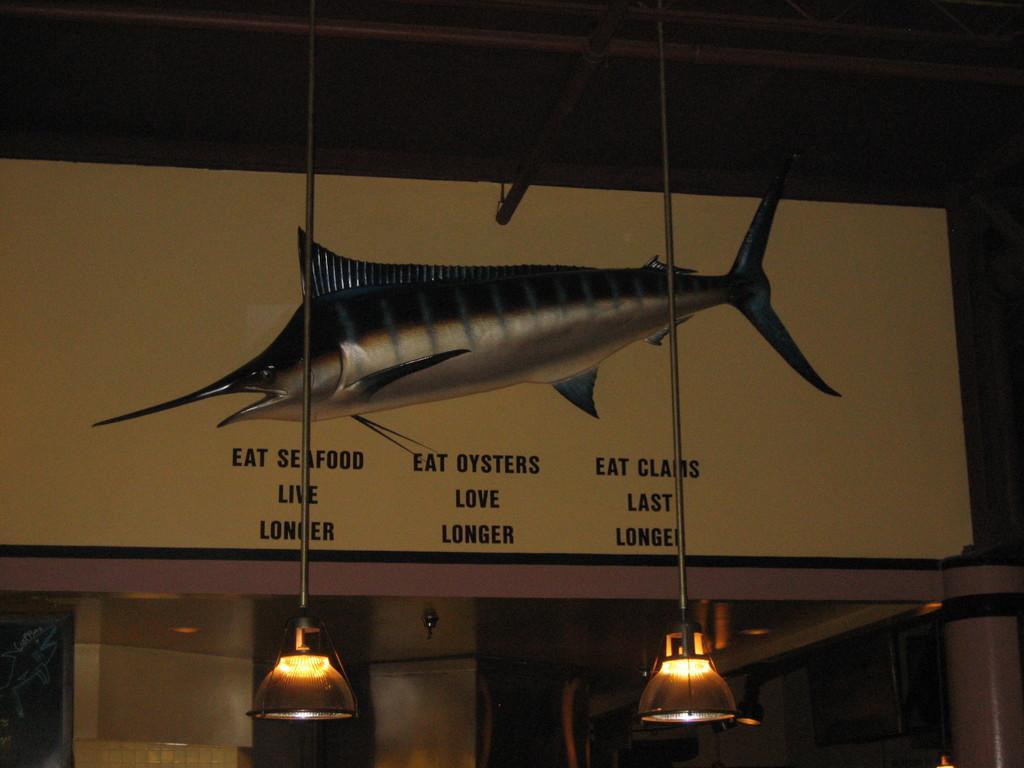Describe this image in one or two sentences. In this image in the center there is a board, on the board there is depiction of a fish and there is text and the bottom there are some lights and poles and also there is wall and objects. And at the top of the image there is ceiling. 